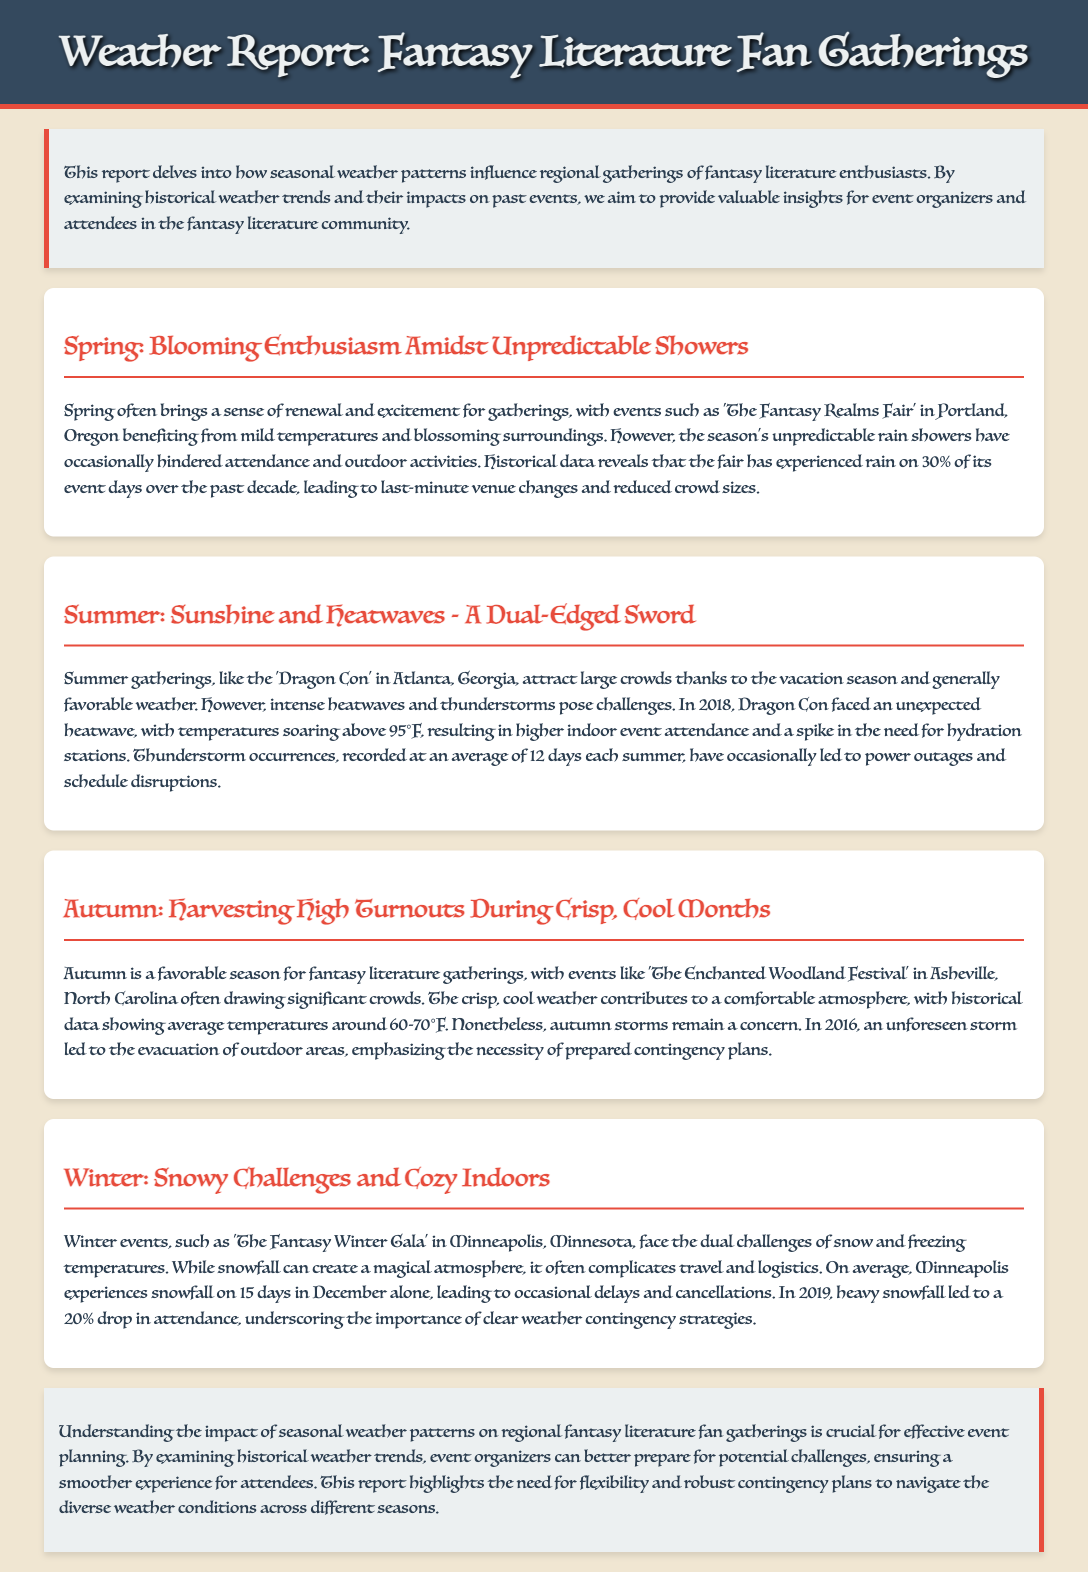What is the title of the report? The title of the report is stated at the top and describes the theme of the document.
Answer: Weather Report: Fantasy Literature Fan Gatherings How often does it rain during the Fantasy Realms Fair? It specifies that rain occurs on 30% of its event days over the past decade.
Answer: 30% What is the average temperature range in autumn events? The document provides historical data showing that average temperatures in autumn are around a specific range.
Answer: 60-70°F What significant weather event affected Dragon Con in 2018? The report notes a temperature condition that was unexpected during the event year.
Answer: Heatwave How many days does Minneapolis typically experience snowfall in December? The document provides a specific number representing the snowfall frequency in Minneapolis.
Answer: 15 days What type of weather is described as a concern during autumn gatherings? The report highlights a specific weather phenomenon that can affect attendance during autumn.
Answer: Storms What major effect did heavy snowfall have on The Fantasy Winter Gala in 2019? The text indicates the impact on event participation related to weather conditions.
Answer: 20% drop in attendance During which season does The Enchanted Woodland Festival take place? The report identifies the seasonal timing of this specific event within the document.
Answer: Autumn What is emphasized as essential for event organizers according to the conclusion? The conclusion highlights a necessity based on seasonal weather patterns and event planning strategies.
Answer: Contingency plans 